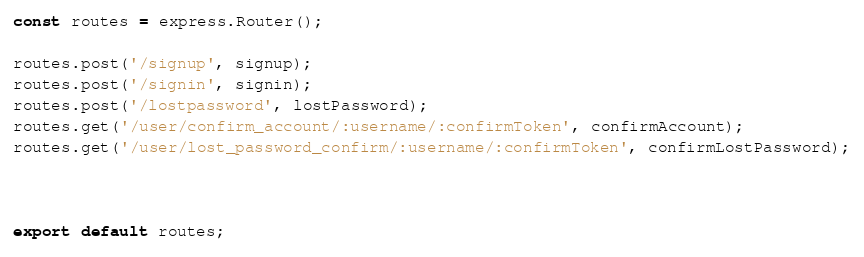<code> <loc_0><loc_0><loc_500><loc_500><_TypeScript_>
const routes = express.Router();

routes.post('/signup', signup);
routes.post('/signin', signin);
routes.post('/lostpassword', lostPassword);
routes.get('/user/confirm_account/:username/:confirmToken', confirmAccount);
routes.get('/user/lost_password_confirm/:username/:confirmToken', confirmLostPassword);



export default routes;</code> 